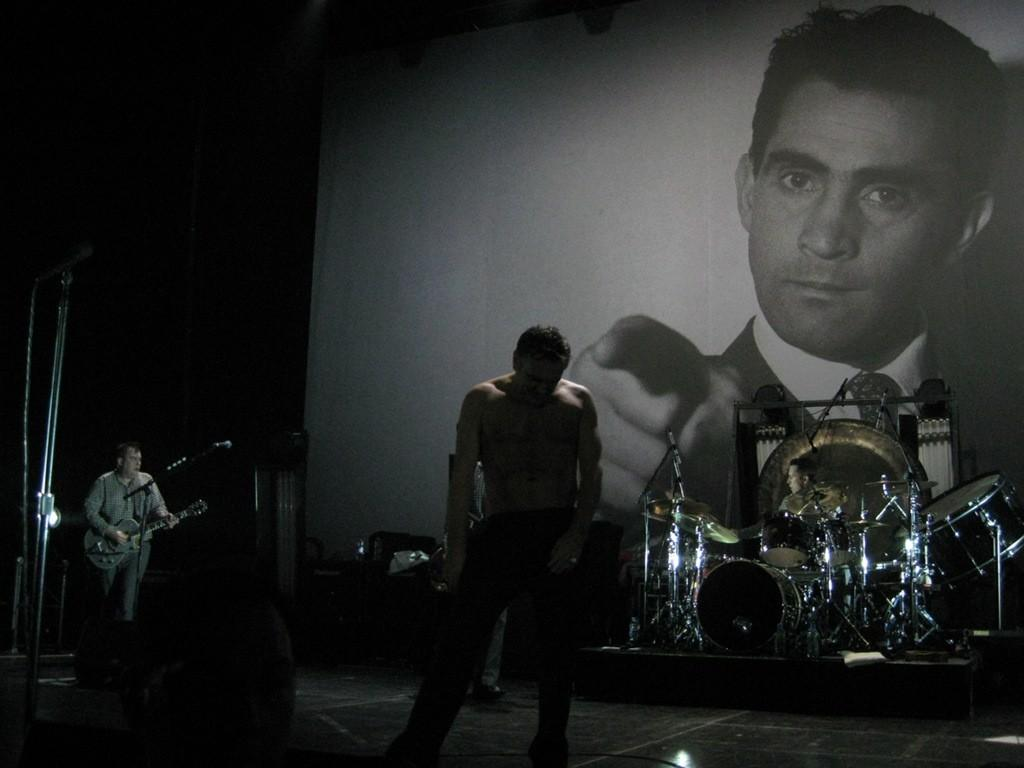What is the man in the image doing? The man is standing in the image. What musical instrument is near the man? There are drums beside the man. What is another person in the image doing? There is a person playing a guitar in the image. Where is the guitar player positioned in relation to the microphone? The guitar player is in front of a microphone. What can be seen in the background of the image? There is a banner in the background of the image. What type of cactus can be seen growing in the background of the image? There is no cactus present in the image; it features a banner in the background. What season is depicted in the image, considering the absence of winter clothing? The image does not provide any information about the season, as it does not show any specific weather or clothing details. 